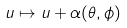Convert formula to latex. <formula><loc_0><loc_0><loc_500><loc_500>u \mapsto u + \alpha ( \theta , \phi )</formula> 